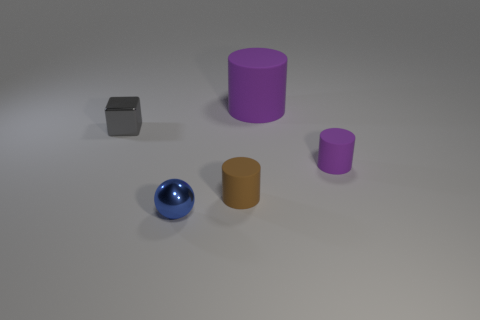Add 4 purple matte objects. How many objects exist? 9 Subtract all balls. How many objects are left? 4 Add 5 tiny brown objects. How many tiny brown objects are left? 6 Add 1 small objects. How many small objects exist? 5 Subtract 0 green cylinders. How many objects are left? 5 Subtract all tiny yellow blocks. Subtract all gray cubes. How many objects are left? 4 